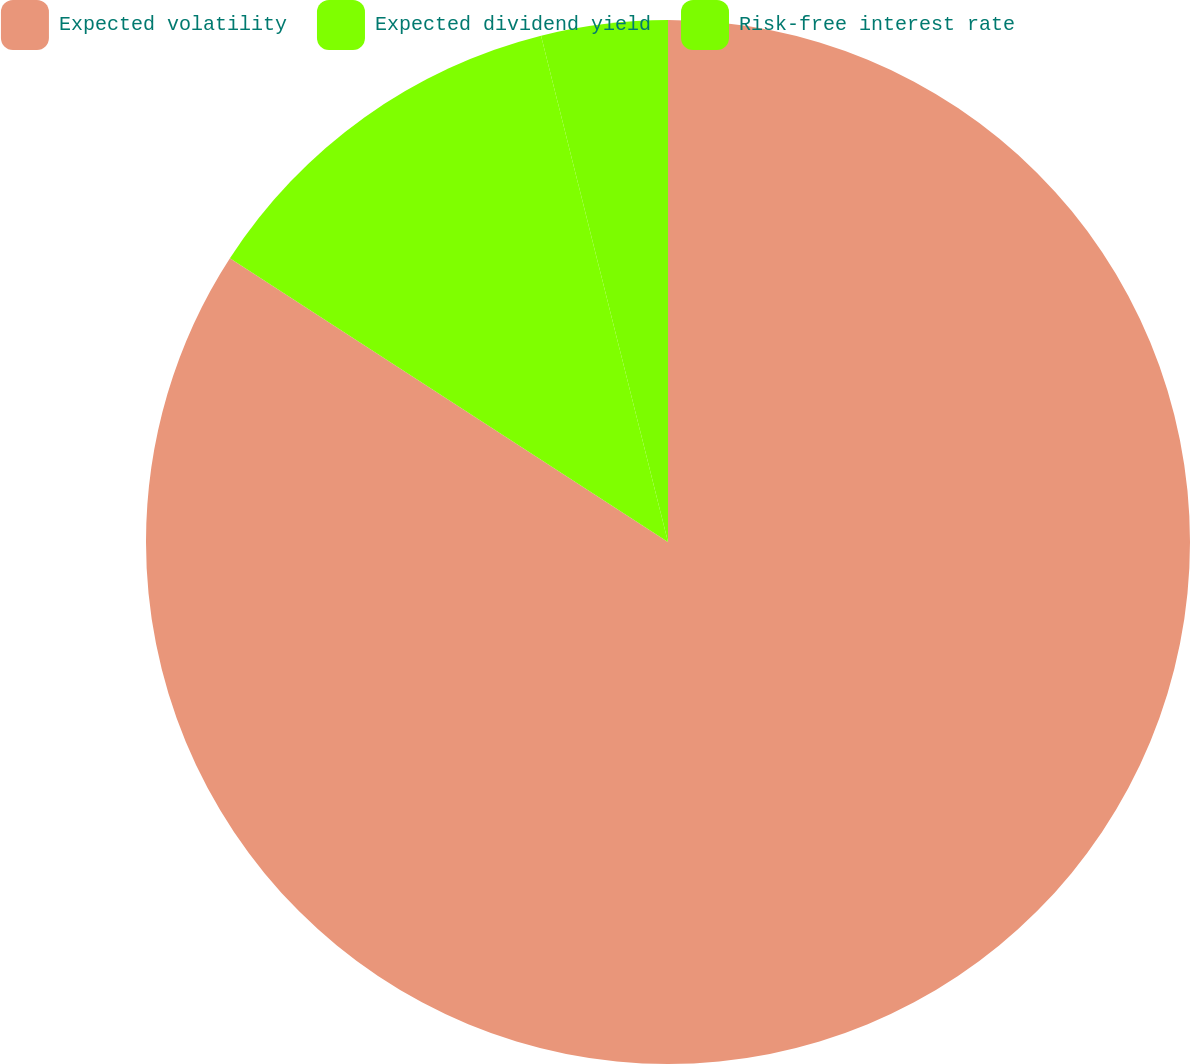Convert chart. <chart><loc_0><loc_0><loc_500><loc_500><pie_chart><fcel>Expected volatility<fcel>Expected dividend yield<fcel>Risk-free interest rate<nl><fcel>84.15%<fcel>11.94%<fcel>3.91%<nl></chart> 